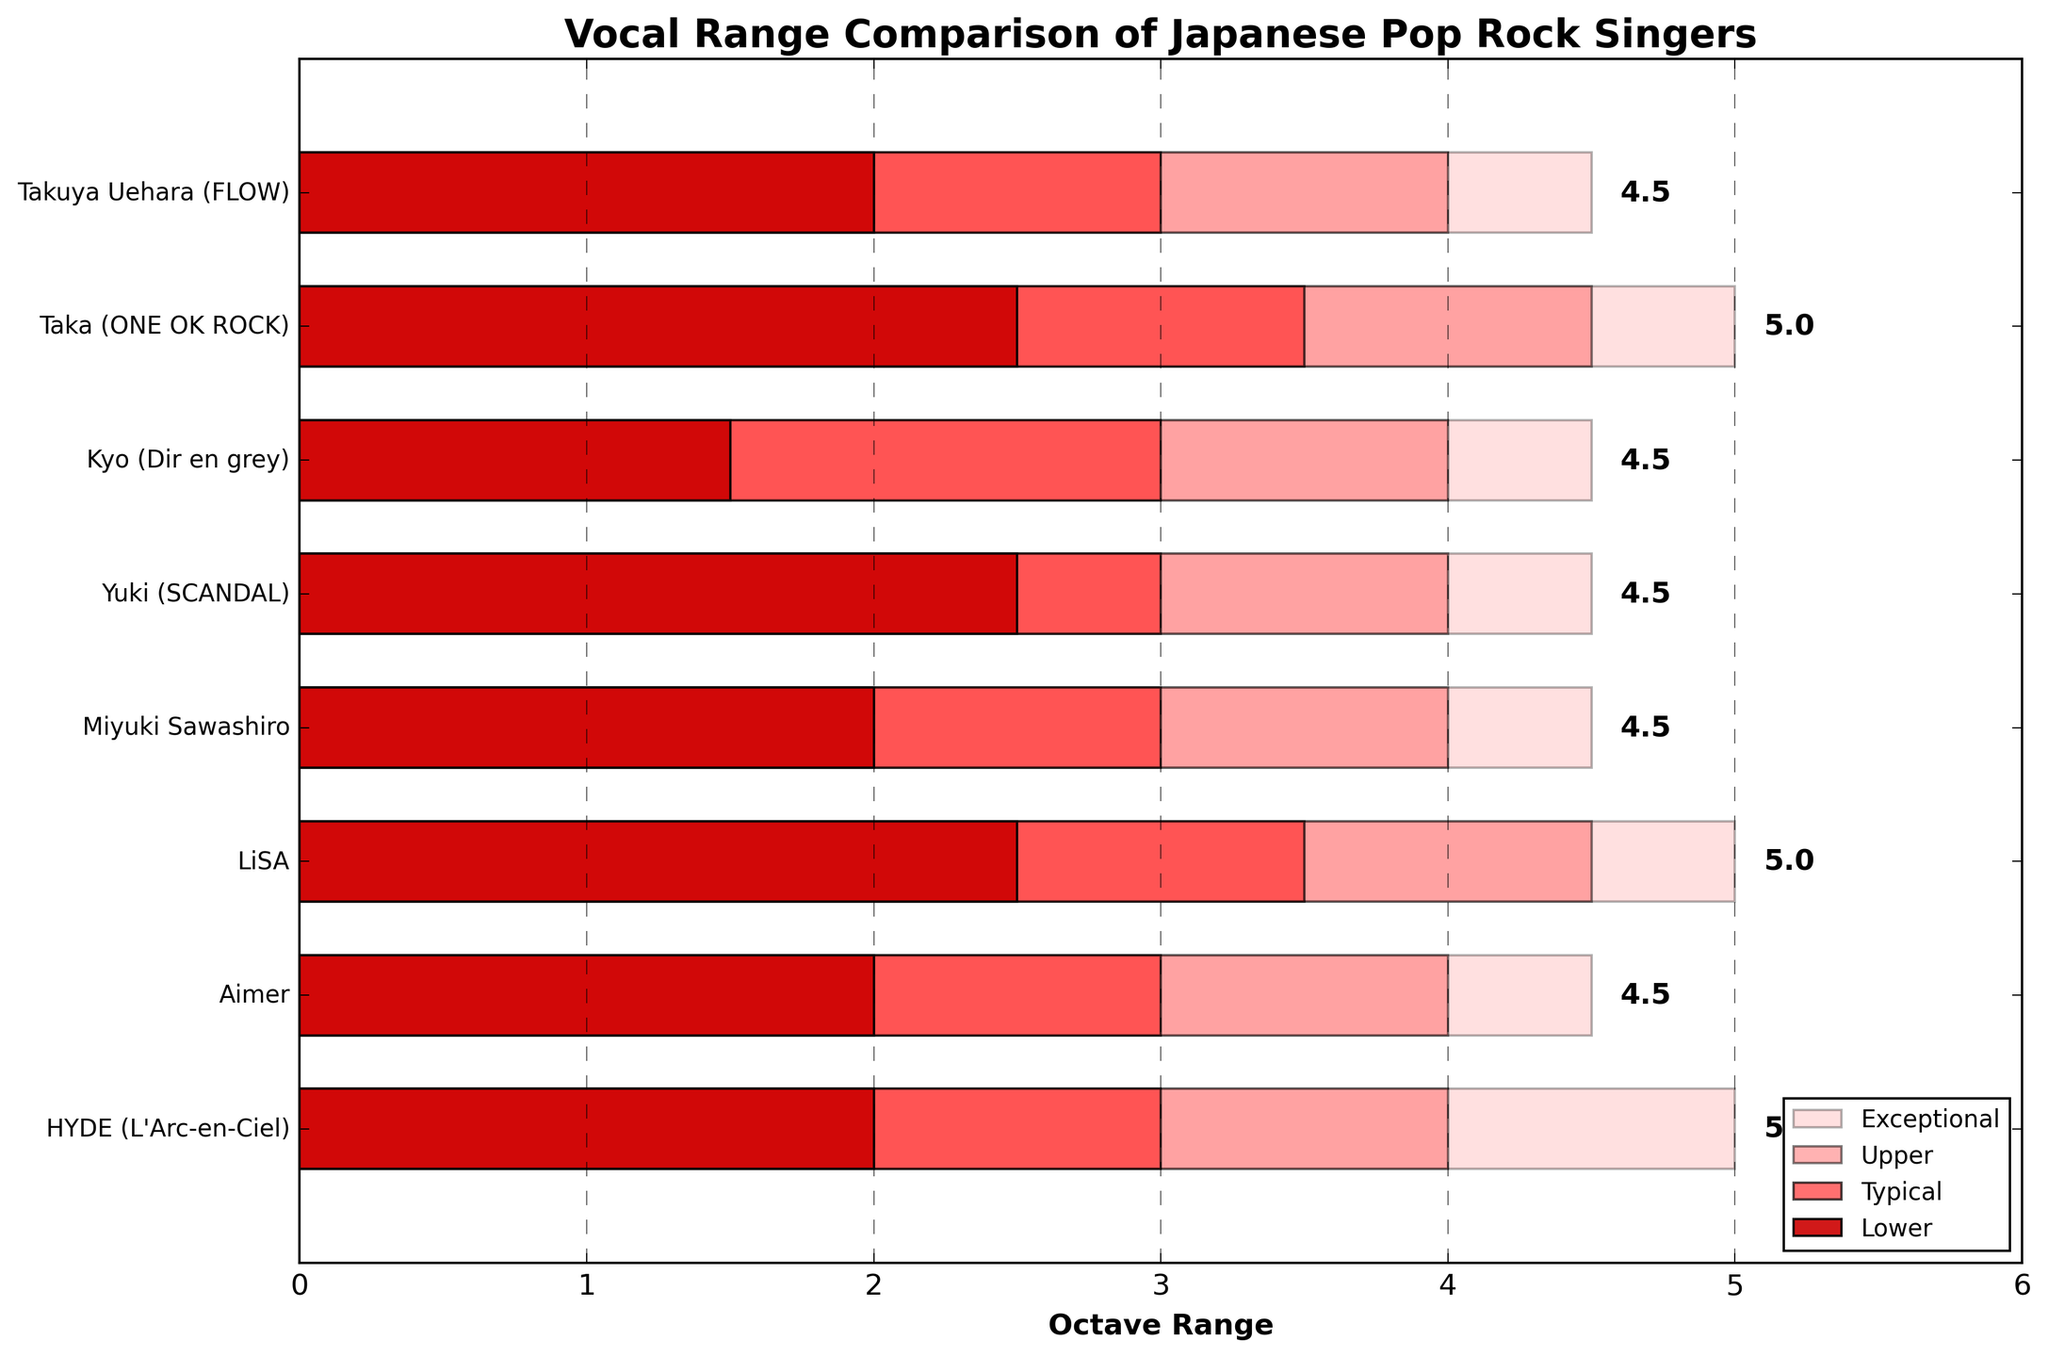What is the upper range octave of Taka (ONE OK ROCK)? The upper range octave of Taka (ONE OK ROCK) can be observed directly from the figure under his respective bar.
Answer: 4.5 Which singer has the highest exceptional range octave? To find the singer with the highest exceptional range octave, compare the exceptional range values for all singers and identify the maximum value. LiSA and Taka both have the highest exceptional range, which is 5.
Answer: LiSA and Taka What is the typical range octave difference between HYDE (L'Arc-en-Ciel) and Aimer? The typical range for HYDE is 3 octaves, and for Aimer, it is also 3 octaves. The difference is calculated as 3 - 3.
Answer: 0 Who has a vocal range spanning from 1.5 octaves? Identify the singer whose range starts at 1.5 octaves; this information can be observed directly from the figure.
Answer: Kyo (Dir en grey) Compare the typical range of Yuki (SCANDAL) and Miyuki Sawashiro. Who has a broader typical range, and by how much? Both Yuki (SCANDAL) and Miyuki Sawashiro have a typical range of 3 octaves each. The difference is 3 - 3 = 0.
Answer: Both have the same typical range What is the total range (from the lowest to the highest exceptional range) for HYDE (L'Arc-en-Ciel)? For HYDE (L'Arc-en-Ciel), the lower range starts at 2 octaves, and the exceptional range peaks at 5 octaves, resulting in a total range of 5 - 2 = 3 octaves.
Answer: 3 octaves Which singer has the broadest typical range and what is it? Look at the figure to find the bars labeled 'Typical'. Taka (ONE OK ROCK) and LiSA both have the broadest typical range of 1.5 octaves (from 2.5 to 4).
Answer: Taka (ONE OK ROCK) and LiSA What is the average upper range octave for all singers? To find the average upper range octave, sum up the upper range values for all singers (4 + 4.5 + 4 + 4 + 4.5 + 4.5 + 4 + 4) and divide by the number of singers (8). The sum is 33.5, and the average is 33.5/8 = 4.1875.
Answer: Approximately 4.19 How many singers have an exceptional range octave equal to or greater than 5? Observe the exceptional range values for all singers and count how many are equal to or greater than 5. Both LiSA and Taka have exceptional ranges of 5 octaves.
Answer: 2 